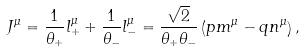<formula> <loc_0><loc_0><loc_500><loc_500>J ^ { \mu } = \frac { 1 } { \theta _ { + } } l ^ { \mu } _ { + } + \frac { 1 } { \theta _ { - } } l ^ { \mu } _ { - } = \frac { \sqrt { 2 } } { \theta _ { + } \theta _ { - } } \left ( p m ^ { \mu } - q n ^ { \mu } \right ) ,</formula> 